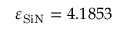Convert formula to latex. <formula><loc_0><loc_0><loc_500><loc_500>\varepsilon _ { S i N } = 4 . 1 8 5 3</formula> 